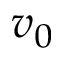<formula> <loc_0><loc_0><loc_500><loc_500>v _ { 0 }</formula> 